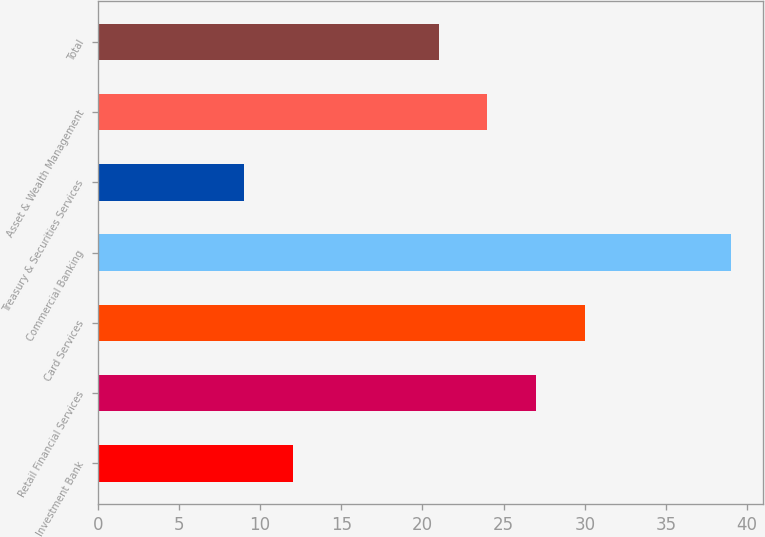Convert chart. <chart><loc_0><loc_0><loc_500><loc_500><bar_chart><fcel>Investment Bank<fcel>Retail Financial Services<fcel>Card Services<fcel>Commercial Banking<fcel>Treasury & Securities Services<fcel>Asset & Wealth Management<fcel>Total<nl><fcel>12<fcel>27<fcel>30<fcel>39<fcel>9<fcel>24<fcel>21<nl></chart> 